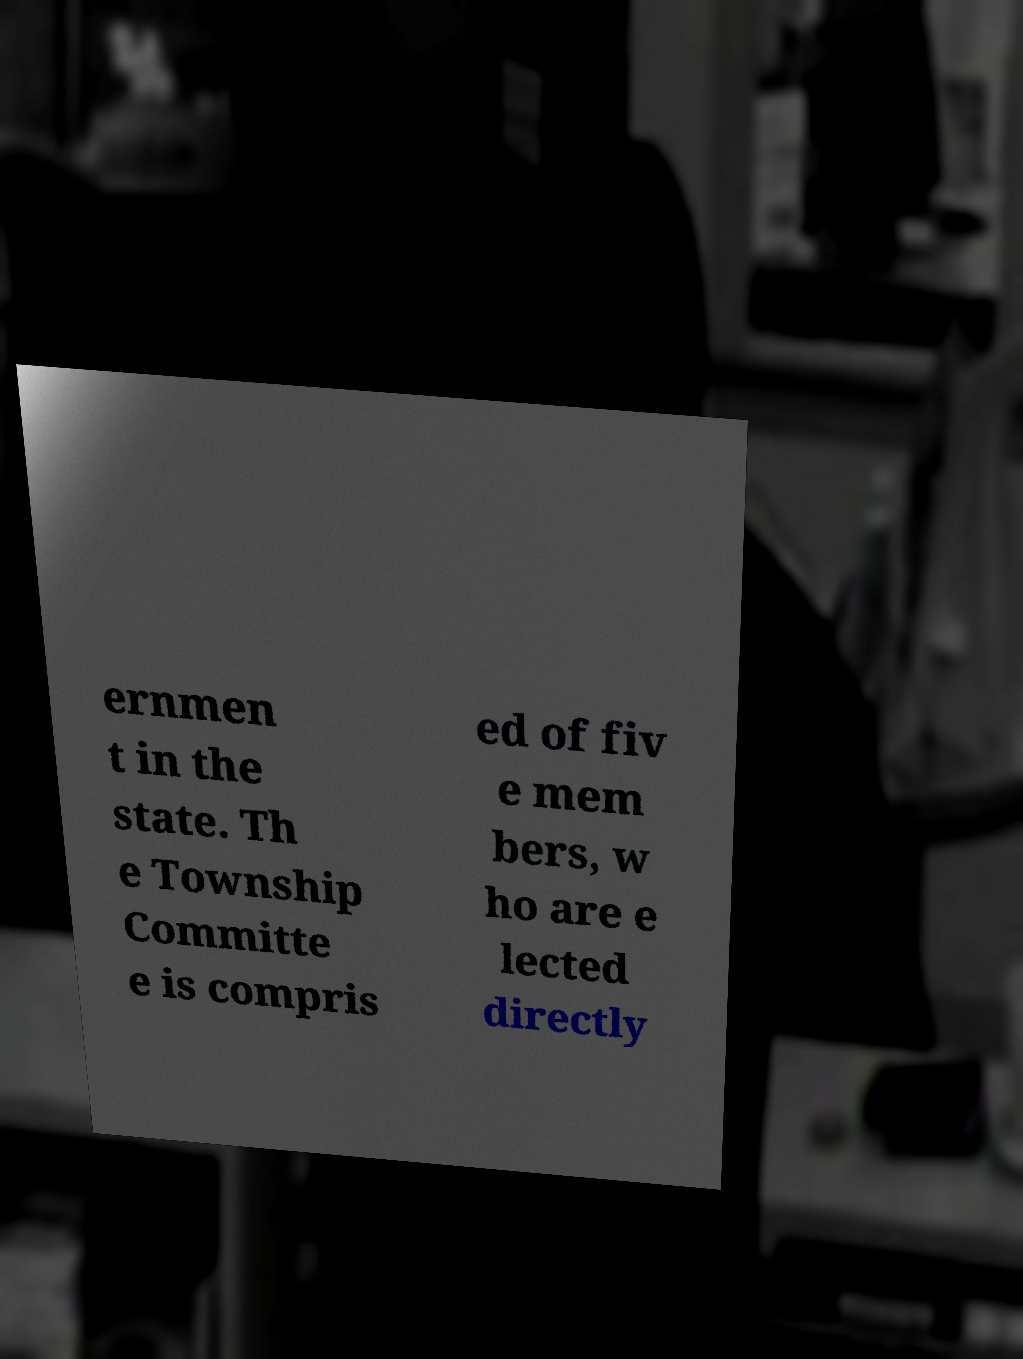Please identify and transcribe the text found in this image. ernmen t in the state. Th e Township Committe e is compris ed of fiv e mem bers, w ho are e lected directly 